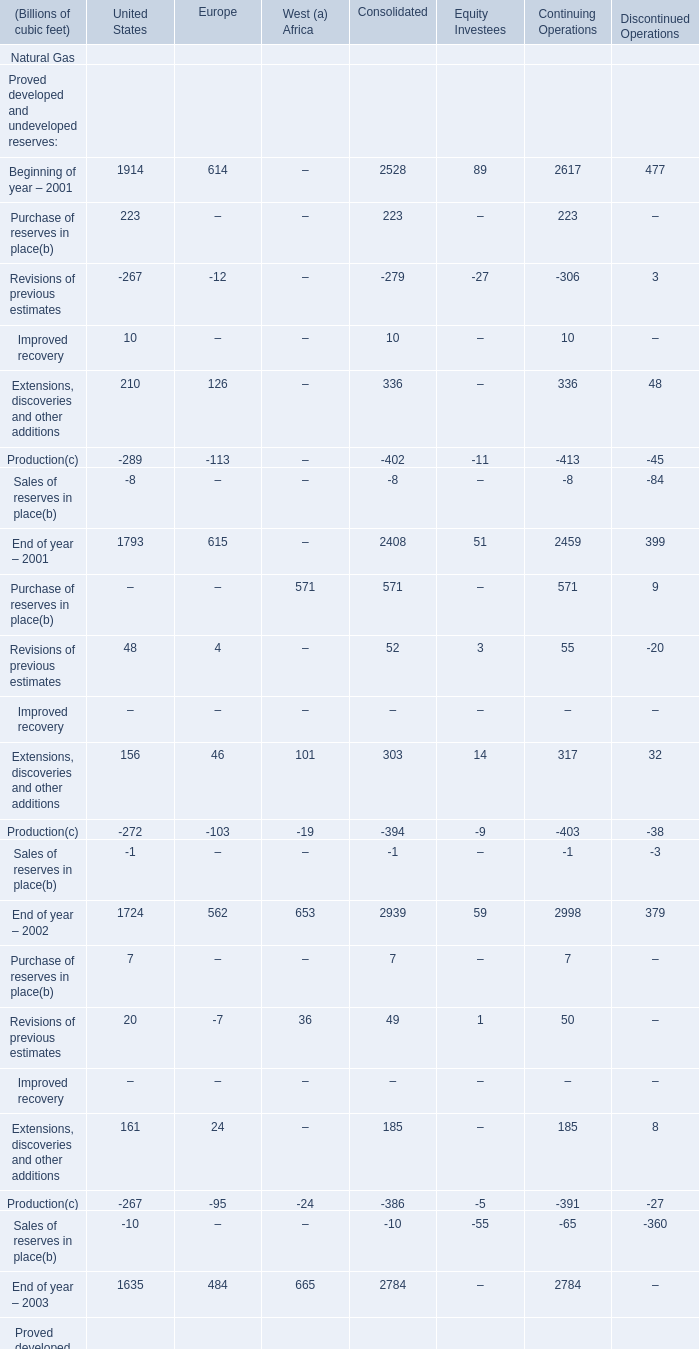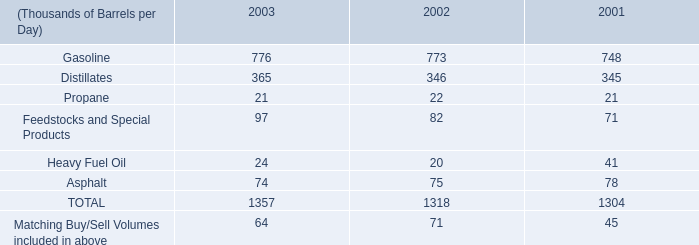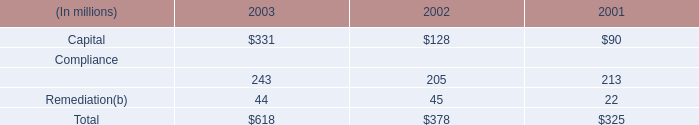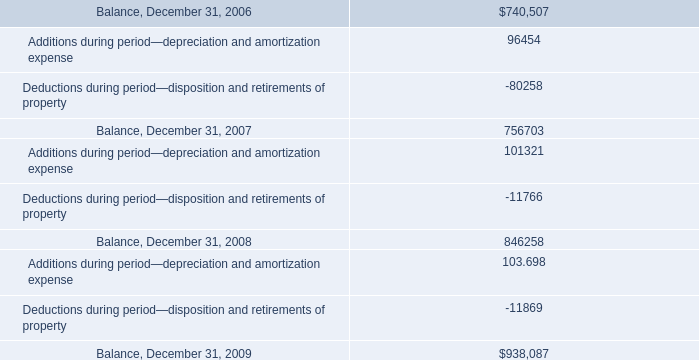For End of year – what is the value of Proved developed reserves in terms of United States the most,between 2001,2002 and 2003? 
Answer: 2001. 